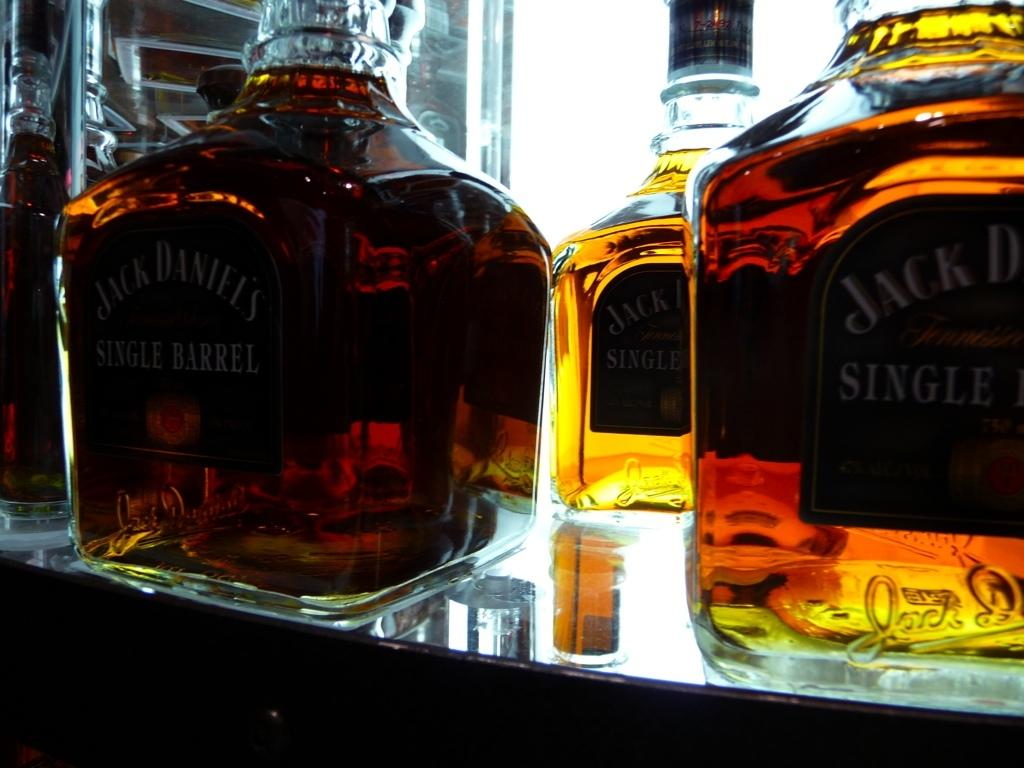<image>
Render a clear and concise summary of the photo. Three bottles of Jack Daniel's single barrel sitting on a glass table. 